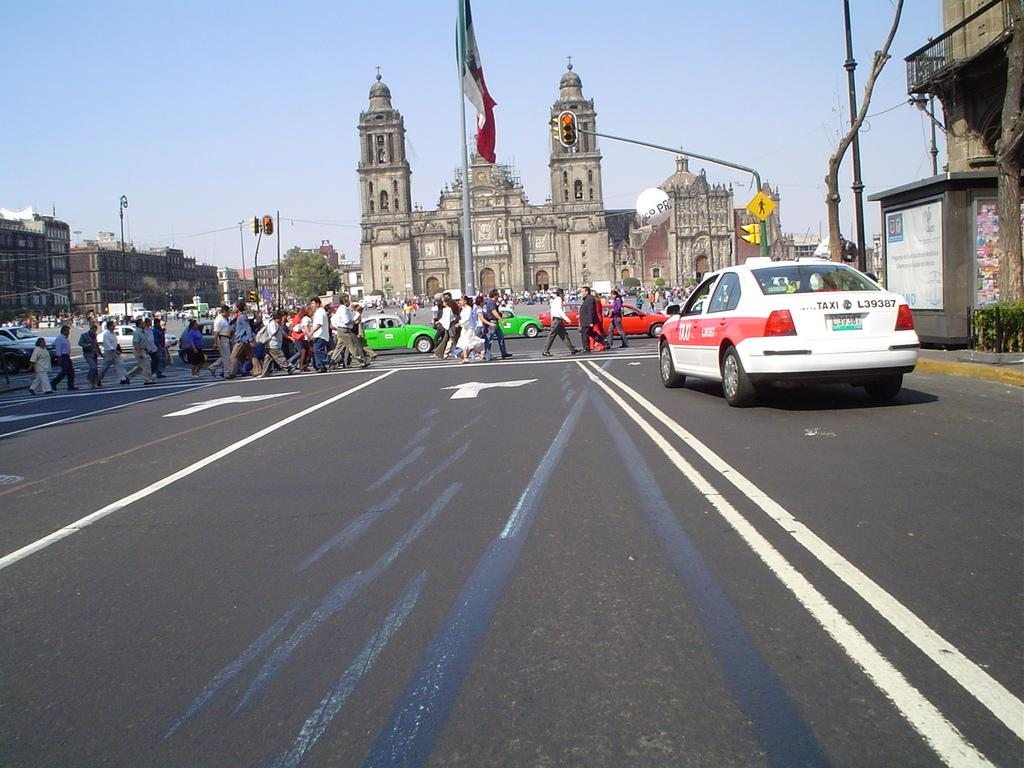<image>
Share a concise interpretation of the image provided. A red and white taxi with a license plate that reads L39387 is driving towards a gothic-looking building. 